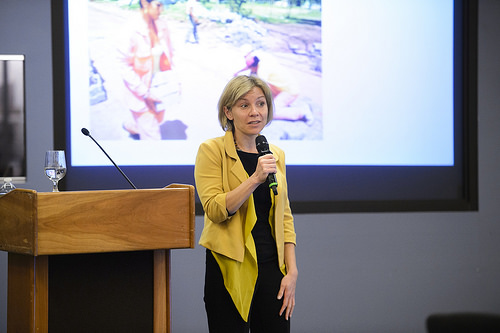<image>
Can you confirm if the screen is above the woman? No. The screen is not positioned above the woman. The vertical arrangement shows a different relationship. 